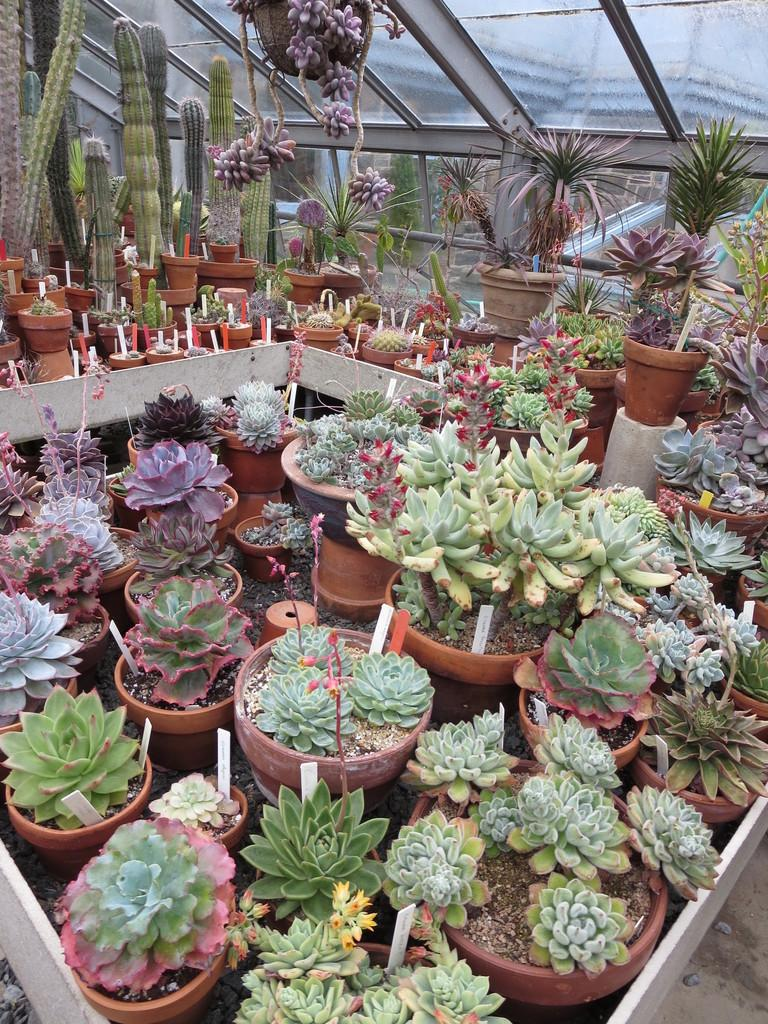What can be found in the flower pots in the image? There are flowers in the flower pots in the image. What type of plants are visible in the background of the image? There are green color cactus plants in the background of the image. What architectural feature is visible at the top of the image? There are glass windows visible at the top of the image. Is there a basketball game happening outside the glass windows in the image? There is no indication of a basketball game or any sports event in the image. 